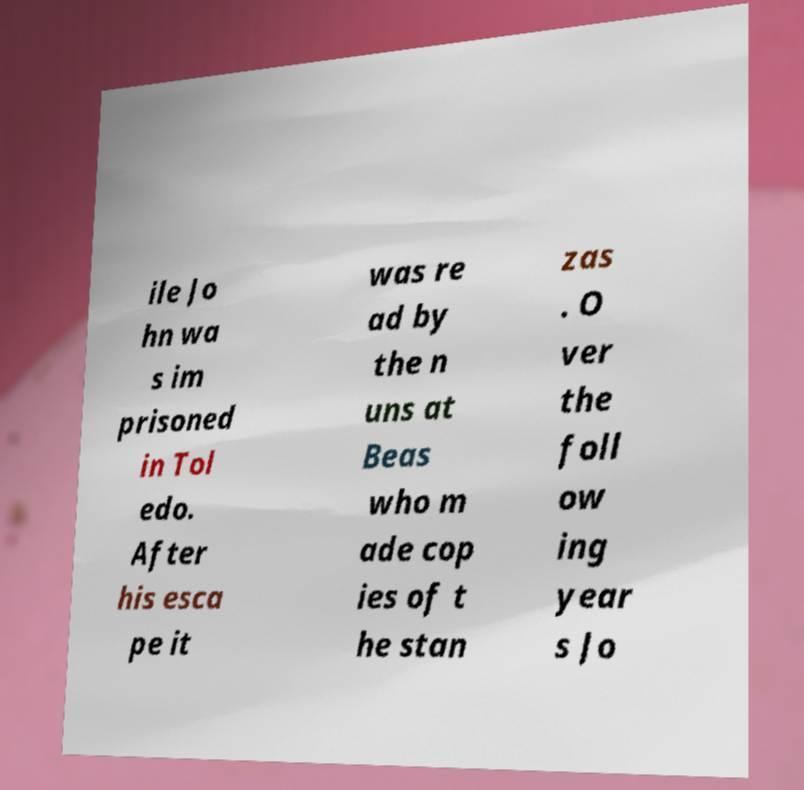I need the written content from this picture converted into text. Can you do that? ile Jo hn wa s im prisoned in Tol edo. After his esca pe it was re ad by the n uns at Beas who m ade cop ies of t he stan zas . O ver the foll ow ing year s Jo 